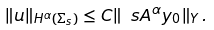Convert formula to latex. <formula><loc_0><loc_0><loc_500><loc_500>\| u \| _ { H ^ { \alpha } ( \Sigma _ { s } ) } \leq C \| \ s A ^ { \alpha } y _ { 0 } \| _ { Y } \, .</formula> 